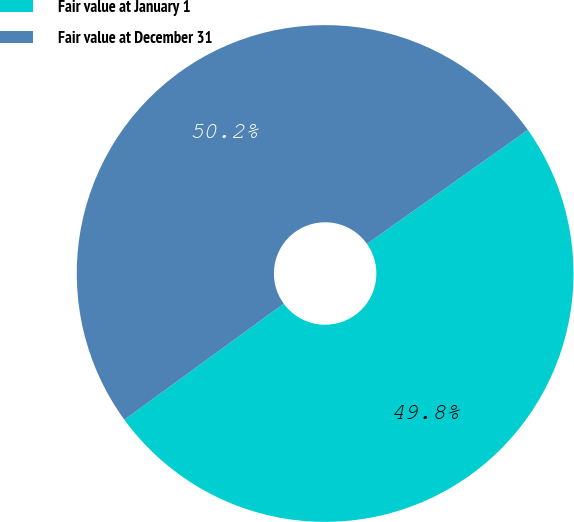<chart> <loc_0><loc_0><loc_500><loc_500><pie_chart><fcel>Fair value at January 1<fcel>Fair value at December 31<nl><fcel>49.79%<fcel>50.21%<nl></chart> 